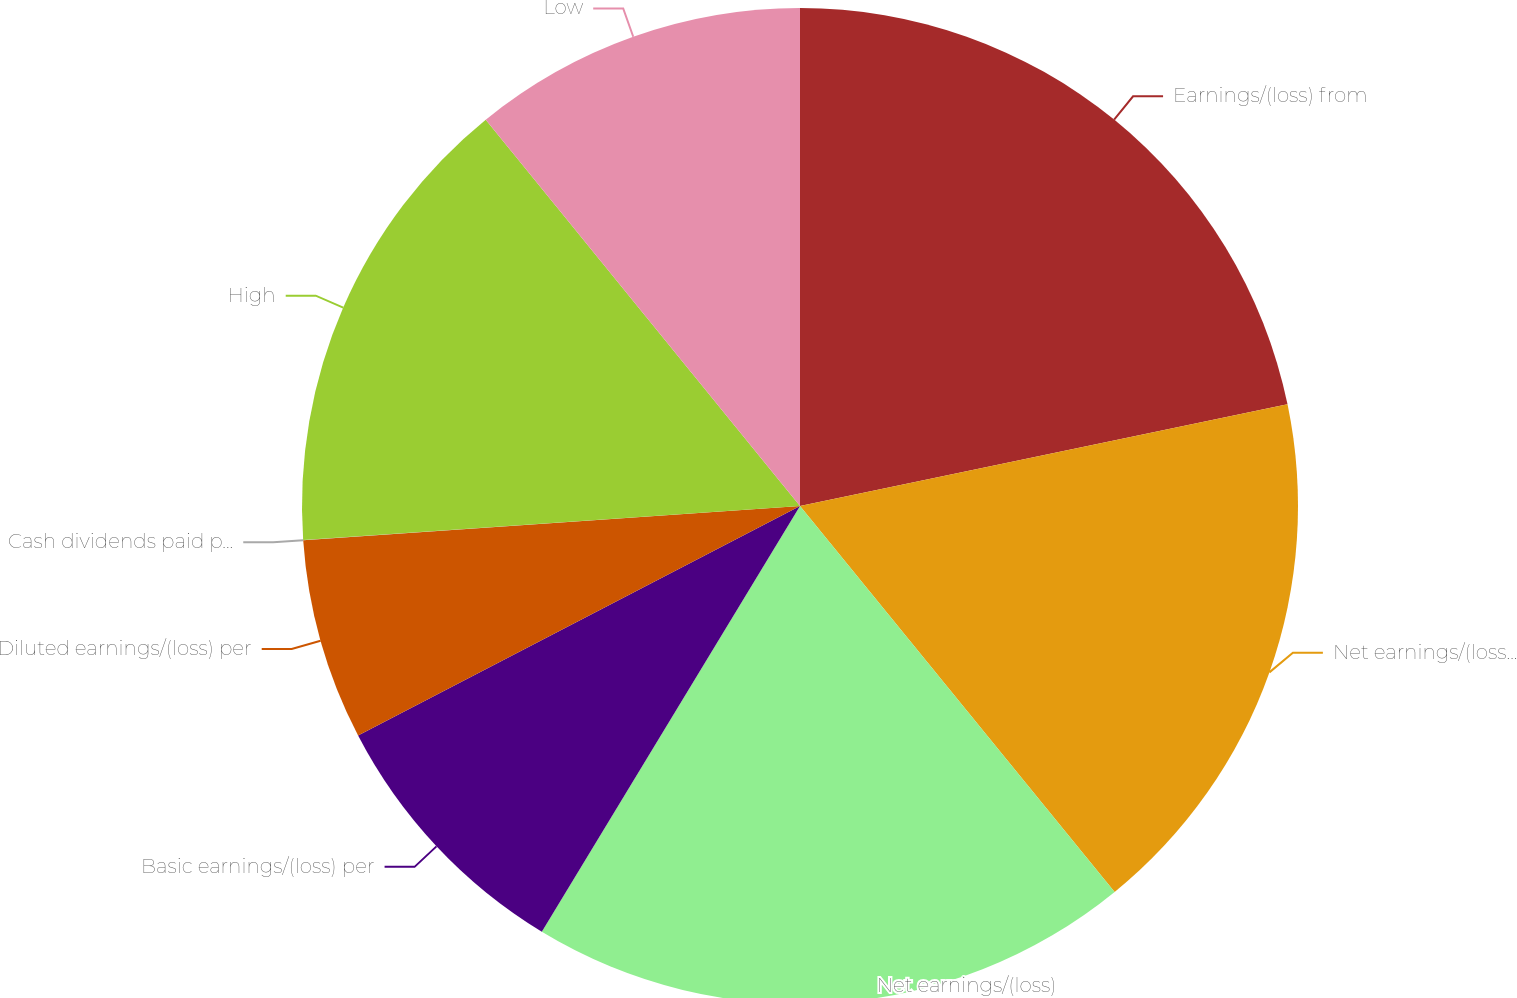<chart> <loc_0><loc_0><loc_500><loc_500><pie_chart><fcel>Earnings/(loss) from<fcel>Net earnings/(loss) from<fcel>Net earnings/(loss)<fcel>Basic earnings/(loss) per<fcel>Diluted earnings/(loss) per<fcel>Cash dividends paid per share<fcel>High<fcel>Low<nl><fcel>21.73%<fcel>17.39%<fcel>19.56%<fcel>8.7%<fcel>6.53%<fcel>0.01%<fcel>15.22%<fcel>10.87%<nl></chart> 